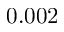Convert formula to latex. <formula><loc_0><loc_0><loc_500><loc_500>0 . 0 0 2</formula> 